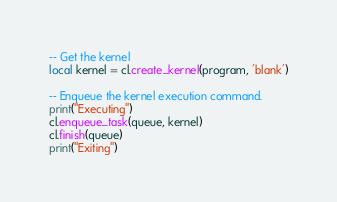<code> <loc_0><loc_0><loc_500><loc_500><_Lua_>
-- Get the kernel
local kernel = cl.create_kernel(program, 'blank')
   
-- Enqueue the kernel execution command. 
print("Executing")
cl.enqueue_task(queue, kernel)
cl.finish(queue)
print("Exiting")

</code> 